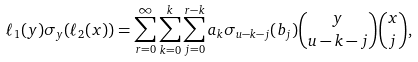<formula> <loc_0><loc_0><loc_500><loc_500>\ell _ { 1 } ( y ) \sigma _ { y } ( \ell _ { 2 } ( x ) ) = \sum _ { r = 0 } ^ { \infty } \sum _ { k = 0 } ^ { k } \sum _ { j = 0 } ^ { r - k } a _ { k } \sigma _ { u - k - j } ( b _ { j } ) \binom { y } { u - k - j } \binom { x } { j } ,</formula> 